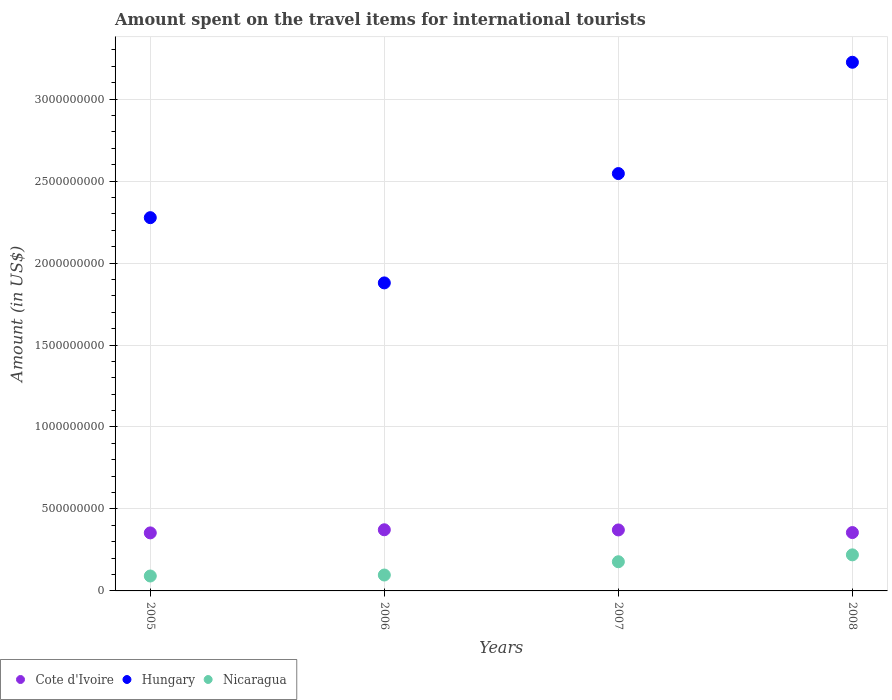What is the amount spent on the travel items for international tourists in Cote d'Ivoire in 2008?
Make the answer very short. 3.56e+08. Across all years, what is the maximum amount spent on the travel items for international tourists in Cote d'Ivoire?
Offer a terse response. 3.73e+08. Across all years, what is the minimum amount spent on the travel items for international tourists in Hungary?
Your answer should be very brief. 1.88e+09. What is the total amount spent on the travel items for international tourists in Hungary in the graph?
Your answer should be very brief. 9.93e+09. What is the difference between the amount spent on the travel items for international tourists in Hungary in 2005 and that in 2006?
Provide a short and direct response. 3.98e+08. What is the difference between the amount spent on the travel items for international tourists in Hungary in 2006 and the amount spent on the travel items for international tourists in Nicaragua in 2008?
Ensure brevity in your answer.  1.66e+09. What is the average amount spent on the travel items for international tourists in Nicaragua per year?
Provide a short and direct response. 1.46e+08. In the year 2007, what is the difference between the amount spent on the travel items for international tourists in Nicaragua and amount spent on the travel items for international tourists in Cote d'Ivoire?
Provide a short and direct response. -1.94e+08. What is the ratio of the amount spent on the travel items for international tourists in Hungary in 2006 to that in 2008?
Your answer should be very brief. 0.58. What is the difference between the highest and the second highest amount spent on the travel items for international tourists in Nicaragua?
Ensure brevity in your answer.  4.20e+07. What is the difference between the highest and the lowest amount spent on the travel items for international tourists in Cote d'Ivoire?
Provide a succinct answer. 1.90e+07. In how many years, is the amount spent on the travel items for international tourists in Nicaragua greater than the average amount spent on the travel items for international tourists in Nicaragua taken over all years?
Give a very brief answer. 2. Is it the case that in every year, the sum of the amount spent on the travel items for international tourists in Cote d'Ivoire and amount spent on the travel items for international tourists in Hungary  is greater than the amount spent on the travel items for international tourists in Nicaragua?
Offer a very short reply. Yes. Is the amount spent on the travel items for international tourists in Nicaragua strictly less than the amount spent on the travel items for international tourists in Cote d'Ivoire over the years?
Make the answer very short. Yes. How many years are there in the graph?
Ensure brevity in your answer.  4. What is the difference between two consecutive major ticks on the Y-axis?
Give a very brief answer. 5.00e+08. Does the graph contain any zero values?
Give a very brief answer. No. Does the graph contain grids?
Your answer should be compact. Yes. Where does the legend appear in the graph?
Make the answer very short. Bottom left. How are the legend labels stacked?
Provide a succinct answer. Horizontal. What is the title of the graph?
Your response must be concise. Amount spent on the travel items for international tourists. Does "North America" appear as one of the legend labels in the graph?
Ensure brevity in your answer.  No. What is the label or title of the Y-axis?
Ensure brevity in your answer.  Amount (in US$). What is the Amount (in US$) of Cote d'Ivoire in 2005?
Offer a terse response. 3.54e+08. What is the Amount (in US$) in Hungary in 2005?
Your response must be concise. 2.28e+09. What is the Amount (in US$) in Nicaragua in 2005?
Offer a very short reply. 9.10e+07. What is the Amount (in US$) in Cote d'Ivoire in 2006?
Your response must be concise. 3.73e+08. What is the Amount (in US$) in Hungary in 2006?
Your answer should be very brief. 1.88e+09. What is the Amount (in US$) of Nicaragua in 2006?
Provide a succinct answer. 9.70e+07. What is the Amount (in US$) of Cote d'Ivoire in 2007?
Offer a terse response. 3.72e+08. What is the Amount (in US$) of Hungary in 2007?
Provide a short and direct response. 2.55e+09. What is the Amount (in US$) in Nicaragua in 2007?
Your response must be concise. 1.78e+08. What is the Amount (in US$) in Cote d'Ivoire in 2008?
Provide a short and direct response. 3.56e+08. What is the Amount (in US$) in Hungary in 2008?
Make the answer very short. 3.22e+09. What is the Amount (in US$) of Nicaragua in 2008?
Your answer should be compact. 2.20e+08. Across all years, what is the maximum Amount (in US$) in Cote d'Ivoire?
Your answer should be compact. 3.73e+08. Across all years, what is the maximum Amount (in US$) of Hungary?
Make the answer very short. 3.22e+09. Across all years, what is the maximum Amount (in US$) in Nicaragua?
Keep it short and to the point. 2.20e+08. Across all years, what is the minimum Amount (in US$) in Cote d'Ivoire?
Give a very brief answer. 3.54e+08. Across all years, what is the minimum Amount (in US$) of Hungary?
Ensure brevity in your answer.  1.88e+09. Across all years, what is the minimum Amount (in US$) in Nicaragua?
Provide a short and direct response. 9.10e+07. What is the total Amount (in US$) of Cote d'Ivoire in the graph?
Provide a succinct answer. 1.46e+09. What is the total Amount (in US$) in Hungary in the graph?
Ensure brevity in your answer.  9.93e+09. What is the total Amount (in US$) of Nicaragua in the graph?
Provide a succinct answer. 5.86e+08. What is the difference between the Amount (in US$) of Cote d'Ivoire in 2005 and that in 2006?
Ensure brevity in your answer.  -1.90e+07. What is the difference between the Amount (in US$) in Hungary in 2005 and that in 2006?
Offer a terse response. 3.98e+08. What is the difference between the Amount (in US$) in Nicaragua in 2005 and that in 2006?
Offer a very short reply. -6.00e+06. What is the difference between the Amount (in US$) of Cote d'Ivoire in 2005 and that in 2007?
Ensure brevity in your answer.  -1.80e+07. What is the difference between the Amount (in US$) of Hungary in 2005 and that in 2007?
Provide a short and direct response. -2.69e+08. What is the difference between the Amount (in US$) in Nicaragua in 2005 and that in 2007?
Offer a terse response. -8.70e+07. What is the difference between the Amount (in US$) in Cote d'Ivoire in 2005 and that in 2008?
Your answer should be very brief. -2.00e+06. What is the difference between the Amount (in US$) in Hungary in 2005 and that in 2008?
Keep it short and to the point. -9.48e+08. What is the difference between the Amount (in US$) in Nicaragua in 2005 and that in 2008?
Your answer should be compact. -1.29e+08. What is the difference between the Amount (in US$) in Cote d'Ivoire in 2006 and that in 2007?
Ensure brevity in your answer.  1.00e+06. What is the difference between the Amount (in US$) of Hungary in 2006 and that in 2007?
Offer a very short reply. -6.67e+08. What is the difference between the Amount (in US$) in Nicaragua in 2006 and that in 2007?
Give a very brief answer. -8.10e+07. What is the difference between the Amount (in US$) in Cote d'Ivoire in 2006 and that in 2008?
Make the answer very short. 1.70e+07. What is the difference between the Amount (in US$) of Hungary in 2006 and that in 2008?
Ensure brevity in your answer.  -1.35e+09. What is the difference between the Amount (in US$) of Nicaragua in 2006 and that in 2008?
Your response must be concise. -1.23e+08. What is the difference between the Amount (in US$) of Cote d'Ivoire in 2007 and that in 2008?
Provide a short and direct response. 1.60e+07. What is the difference between the Amount (in US$) of Hungary in 2007 and that in 2008?
Give a very brief answer. -6.79e+08. What is the difference between the Amount (in US$) of Nicaragua in 2007 and that in 2008?
Your response must be concise. -4.20e+07. What is the difference between the Amount (in US$) in Cote d'Ivoire in 2005 and the Amount (in US$) in Hungary in 2006?
Your answer should be compact. -1.52e+09. What is the difference between the Amount (in US$) in Cote d'Ivoire in 2005 and the Amount (in US$) in Nicaragua in 2006?
Your answer should be compact. 2.57e+08. What is the difference between the Amount (in US$) in Hungary in 2005 and the Amount (in US$) in Nicaragua in 2006?
Make the answer very short. 2.18e+09. What is the difference between the Amount (in US$) of Cote d'Ivoire in 2005 and the Amount (in US$) of Hungary in 2007?
Your answer should be compact. -2.19e+09. What is the difference between the Amount (in US$) in Cote d'Ivoire in 2005 and the Amount (in US$) in Nicaragua in 2007?
Your response must be concise. 1.76e+08. What is the difference between the Amount (in US$) of Hungary in 2005 and the Amount (in US$) of Nicaragua in 2007?
Keep it short and to the point. 2.10e+09. What is the difference between the Amount (in US$) of Cote d'Ivoire in 2005 and the Amount (in US$) of Hungary in 2008?
Make the answer very short. -2.87e+09. What is the difference between the Amount (in US$) of Cote d'Ivoire in 2005 and the Amount (in US$) of Nicaragua in 2008?
Ensure brevity in your answer.  1.34e+08. What is the difference between the Amount (in US$) in Hungary in 2005 and the Amount (in US$) in Nicaragua in 2008?
Keep it short and to the point. 2.06e+09. What is the difference between the Amount (in US$) of Cote d'Ivoire in 2006 and the Amount (in US$) of Hungary in 2007?
Offer a terse response. -2.17e+09. What is the difference between the Amount (in US$) of Cote d'Ivoire in 2006 and the Amount (in US$) of Nicaragua in 2007?
Make the answer very short. 1.95e+08. What is the difference between the Amount (in US$) of Hungary in 2006 and the Amount (in US$) of Nicaragua in 2007?
Provide a succinct answer. 1.70e+09. What is the difference between the Amount (in US$) of Cote d'Ivoire in 2006 and the Amount (in US$) of Hungary in 2008?
Give a very brief answer. -2.85e+09. What is the difference between the Amount (in US$) of Cote d'Ivoire in 2006 and the Amount (in US$) of Nicaragua in 2008?
Offer a terse response. 1.53e+08. What is the difference between the Amount (in US$) of Hungary in 2006 and the Amount (in US$) of Nicaragua in 2008?
Your response must be concise. 1.66e+09. What is the difference between the Amount (in US$) of Cote d'Ivoire in 2007 and the Amount (in US$) of Hungary in 2008?
Ensure brevity in your answer.  -2.85e+09. What is the difference between the Amount (in US$) of Cote d'Ivoire in 2007 and the Amount (in US$) of Nicaragua in 2008?
Your answer should be very brief. 1.52e+08. What is the difference between the Amount (in US$) of Hungary in 2007 and the Amount (in US$) of Nicaragua in 2008?
Provide a succinct answer. 2.33e+09. What is the average Amount (in US$) of Cote d'Ivoire per year?
Your answer should be very brief. 3.64e+08. What is the average Amount (in US$) in Hungary per year?
Keep it short and to the point. 2.48e+09. What is the average Amount (in US$) in Nicaragua per year?
Keep it short and to the point. 1.46e+08. In the year 2005, what is the difference between the Amount (in US$) of Cote d'Ivoire and Amount (in US$) of Hungary?
Your response must be concise. -1.92e+09. In the year 2005, what is the difference between the Amount (in US$) in Cote d'Ivoire and Amount (in US$) in Nicaragua?
Provide a short and direct response. 2.63e+08. In the year 2005, what is the difference between the Amount (in US$) in Hungary and Amount (in US$) in Nicaragua?
Offer a very short reply. 2.19e+09. In the year 2006, what is the difference between the Amount (in US$) of Cote d'Ivoire and Amount (in US$) of Hungary?
Offer a terse response. -1.51e+09. In the year 2006, what is the difference between the Amount (in US$) in Cote d'Ivoire and Amount (in US$) in Nicaragua?
Give a very brief answer. 2.76e+08. In the year 2006, what is the difference between the Amount (in US$) of Hungary and Amount (in US$) of Nicaragua?
Give a very brief answer. 1.78e+09. In the year 2007, what is the difference between the Amount (in US$) of Cote d'Ivoire and Amount (in US$) of Hungary?
Provide a short and direct response. -2.17e+09. In the year 2007, what is the difference between the Amount (in US$) in Cote d'Ivoire and Amount (in US$) in Nicaragua?
Offer a terse response. 1.94e+08. In the year 2007, what is the difference between the Amount (in US$) of Hungary and Amount (in US$) of Nicaragua?
Make the answer very short. 2.37e+09. In the year 2008, what is the difference between the Amount (in US$) in Cote d'Ivoire and Amount (in US$) in Hungary?
Provide a succinct answer. -2.87e+09. In the year 2008, what is the difference between the Amount (in US$) in Cote d'Ivoire and Amount (in US$) in Nicaragua?
Provide a short and direct response. 1.36e+08. In the year 2008, what is the difference between the Amount (in US$) of Hungary and Amount (in US$) of Nicaragua?
Provide a short and direct response. 3.00e+09. What is the ratio of the Amount (in US$) in Cote d'Ivoire in 2005 to that in 2006?
Your answer should be compact. 0.95. What is the ratio of the Amount (in US$) in Hungary in 2005 to that in 2006?
Give a very brief answer. 1.21. What is the ratio of the Amount (in US$) in Nicaragua in 2005 to that in 2006?
Keep it short and to the point. 0.94. What is the ratio of the Amount (in US$) of Cote d'Ivoire in 2005 to that in 2007?
Make the answer very short. 0.95. What is the ratio of the Amount (in US$) in Hungary in 2005 to that in 2007?
Provide a short and direct response. 0.89. What is the ratio of the Amount (in US$) in Nicaragua in 2005 to that in 2007?
Keep it short and to the point. 0.51. What is the ratio of the Amount (in US$) in Hungary in 2005 to that in 2008?
Give a very brief answer. 0.71. What is the ratio of the Amount (in US$) of Nicaragua in 2005 to that in 2008?
Your answer should be compact. 0.41. What is the ratio of the Amount (in US$) of Hungary in 2006 to that in 2007?
Keep it short and to the point. 0.74. What is the ratio of the Amount (in US$) in Nicaragua in 2006 to that in 2007?
Your answer should be compact. 0.54. What is the ratio of the Amount (in US$) in Cote d'Ivoire in 2006 to that in 2008?
Offer a terse response. 1.05. What is the ratio of the Amount (in US$) of Hungary in 2006 to that in 2008?
Offer a very short reply. 0.58. What is the ratio of the Amount (in US$) in Nicaragua in 2006 to that in 2008?
Offer a very short reply. 0.44. What is the ratio of the Amount (in US$) of Cote d'Ivoire in 2007 to that in 2008?
Offer a terse response. 1.04. What is the ratio of the Amount (in US$) in Hungary in 2007 to that in 2008?
Offer a terse response. 0.79. What is the ratio of the Amount (in US$) in Nicaragua in 2007 to that in 2008?
Offer a terse response. 0.81. What is the difference between the highest and the second highest Amount (in US$) in Cote d'Ivoire?
Keep it short and to the point. 1.00e+06. What is the difference between the highest and the second highest Amount (in US$) in Hungary?
Ensure brevity in your answer.  6.79e+08. What is the difference between the highest and the second highest Amount (in US$) in Nicaragua?
Keep it short and to the point. 4.20e+07. What is the difference between the highest and the lowest Amount (in US$) of Cote d'Ivoire?
Keep it short and to the point. 1.90e+07. What is the difference between the highest and the lowest Amount (in US$) in Hungary?
Provide a short and direct response. 1.35e+09. What is the difference between the highest and the lowest Amount (in US$) of Nicaragua?
Offer a terse response. 1.29e+08. 